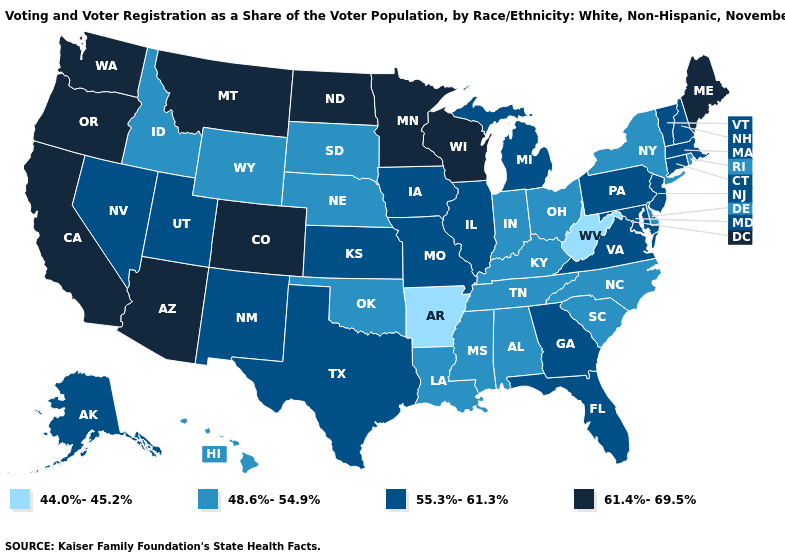What is the lowest value in the South?
Concise answer only. 44.0%-45.2%. Does West Virginia have the lowest value in the USA?
Keep it brief. Yes. Which states have the highest value in the USA?
Short answer required. Arizona, California, Colorado, Maine, Minnesota, Montana, North Dakota, Oregon, Washington, Wisconsin. What is the value of South Dakota?
Give a very brief answer. 48.6%-54.9%. Among the states that border Maryland , does Virginia have the lowest value?
Answer briefly. No. Among the states that border Texas , does Oklahoma have the highest value?
Answer briefly. No. What is the highest value in states that border Montana?
Give a very brief answer. 61.4%-69.5%. Name the states that have a value in the range 48.6%-54.9%?
Quick response, please. Alabama, Delaware, Hawaii, Idaho, Indiana, Kentucky, Louisiana, Mississippi, Nebraska, New York, North Carolina, Ohio, Oklahoma, Rhode Island, South Carolina, South Dakota, Tennessee, Wyoming. What is the value of Nebraska?
Concise answer only. 48.6%-54.9%. Does Idaho have the highest value in the West?
Short answer required. No. Name the states that have a value in the range 48.6%-54.9%?
Concise answer only. Alabama, Delaware, Hawaii, Idaho, Indiana, Kentucky, Louisiana, Mississippi, Nebraska, New York, North Carolina, Ohio, Oklahoma, Rhode Island, South Carolina, South Dakota, Tennessee, Wyoming. What is the value of New Mexico?
Answer briefly. 55.3%-61.3%. Name the states that have a value in the range 48.6%-54.9%?
Be succinct. Alabama, Delaware, Hawaii, Idaho, Indiana, Kentucky, Louisiana, Mississippi, Nebraska, New York, North Carolina, Ohio, Oklahoma, Rhode Island, South Carolina, South Dakota, Tennessee, Wyoming. Name the states that have a value in the range 48.6%-54.9%?
Keep it brief. Alabama, Delaware, Hawaii, Idaho, Indiana, Kentucky, Louisiana, Mississippi, Nebraska, New York, North Carolina, Ohio, Oklahoma, Rhode Island, South Carolina, South Dakota, Tennessee, Wyoming. 